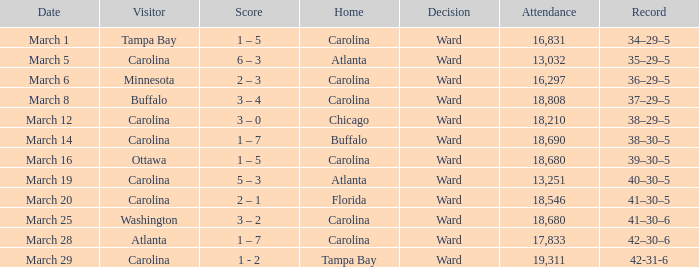What is the Record when Buffalo is at Home? 38–30–5. 